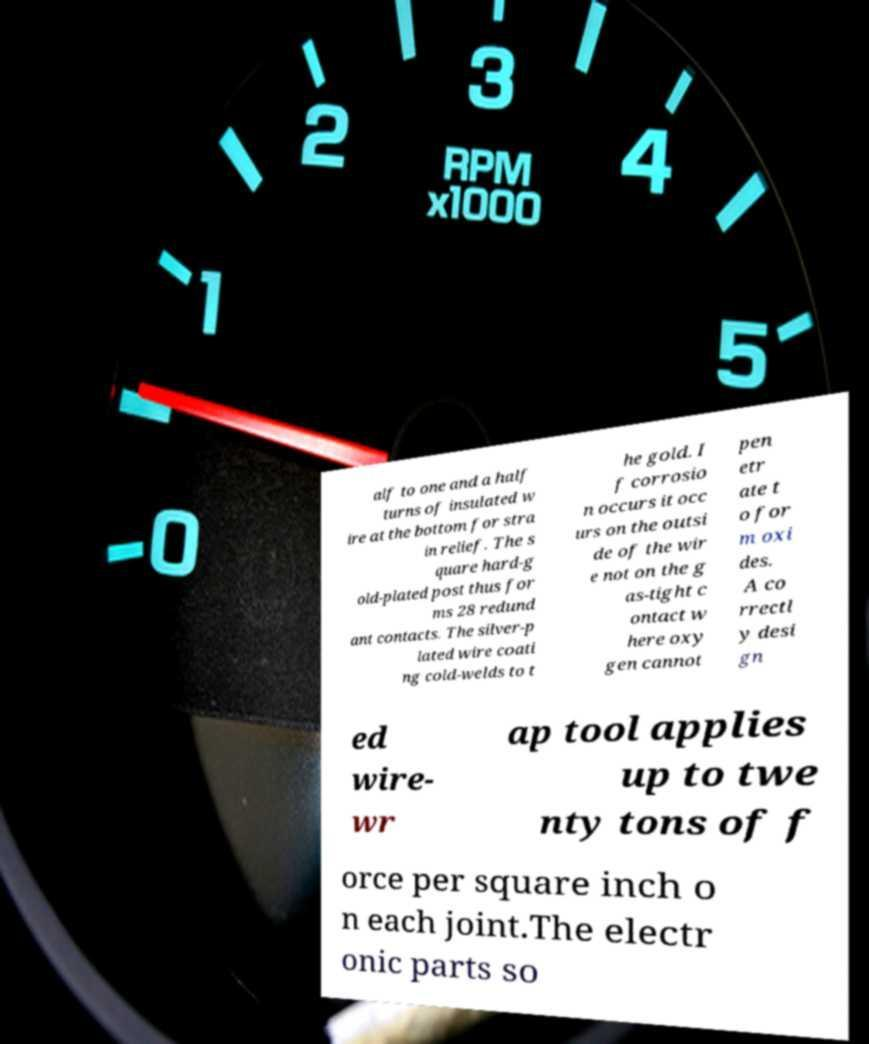Could you extract and type out the text from this image? alf to one and a half turns of insulated w ire at the bottom for stra in relief. The s quare hard-g old-plated post thus for ms 28 redund ant contacts. The silver-p lated wire coati ng cold-welds to t he gold. I f corrosio n occurs it occ urs on the outsi de of the wir e not on the g as-tight c ontact w here oxy gen cannot pen etr ate t o for m oxi des. A co rrectl y desi gn ed wire- wr ap tool applies up to twe nty tons of f orce per square inch o n each joint.The electr onic parts so 